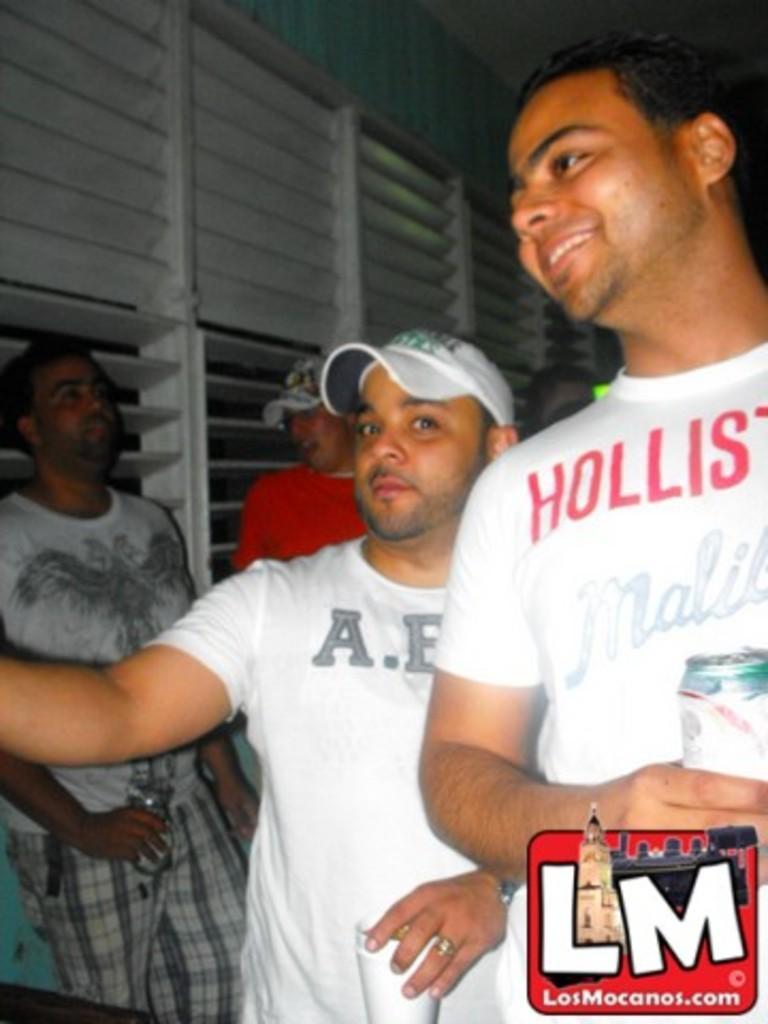How would you summarize this image in a sentence or two? In this image, we can see some people standing and we can see the windows. 